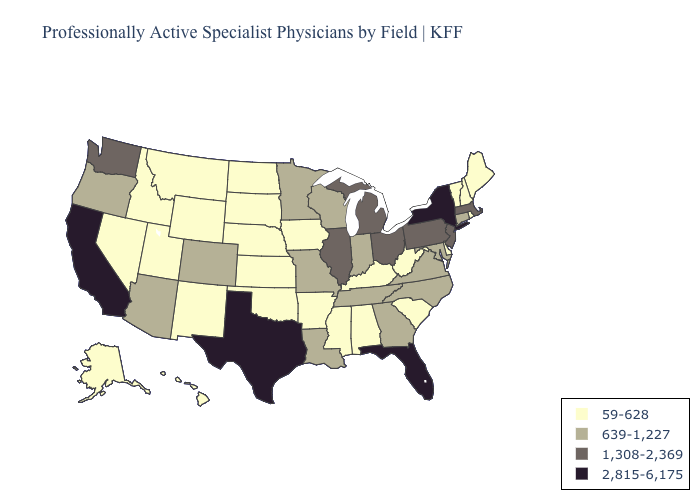Which states have the highest value in the USA?
Give a very brief answer. California, Florida, New York, Texas. What is the value of Hawaii?
Concise answer only. 59-628. What is the value of Hawaii?
Be succinct. 59-628. Does Wisconsin have the highest value in the USA?
Be succinct. No. Name the states that have a value in the range 1,308-2,369?
Be succinct. Illinois, Massachusetts, Michigan, New Jersey, Ohio, Pennsylvania, Washington. Which states have the lowest value in the USA?
Quick response, please. Alabama, Alaska, Arkansas, Delaware, Hawaii, Idaho, Iowa, Kansas, Kentucky, Maine, Mississippi, Montana, Nebraska, Nevada, New Hampshire, New Mexico, North Dakota, Oklahoma, Rhode Island, South Carolina, South Dakota, Utah, Vermont, West Virginia, Wyoming. What is the highest value in states that border Washington?
Concise answer only. 639-1,227. What is the highest value in states that border Tennessee?
Be succinct. 639-1,227. Is the legend a continuous bar?
Keep it brief. No. How many symbols are there in the legend?
Concise answer only. 4. What is the value of Virginia?
Give a very brief answer. 639-1,227. What is the value of West Virginia?
Write a very short answer. 59-628. What is the value of Indiana?
Be succinct. 639-1,227. Name the states that have a value in the range 2,815-6,175?
Short answer required. California, Florida, New York, Texas. Which states have the lowest value in the USA?
Be succinct. Alabama, Alaska, Arkansas, Delaware, Hawaii, Idaho, Iowa, Kansas, Kentucky, Maine, Mississippi, Montana, Nebraska, Nevada, New Hampshire, New Mexico, North Dakota, Oklahoma, Rhode Island, South Carolina, South Dakota, Utah, Vermont, West Virginia, Wyoming. 